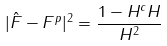<formula> <loc_0><loc_0><loc_500><loc_500>| \hat { F } - F ^ { p } | ^ { 2 } = \frac { 1 - H ^ { c } H } { H ^ { 2 } }</formula> 